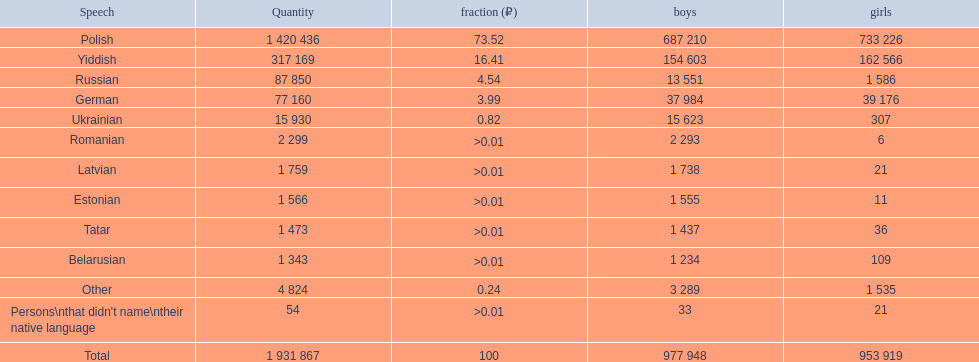What is the percentage of polish speakers? 73.52. What is the next highest percentage of speakers? 16.41. What language is this percentage? Yiddish. 